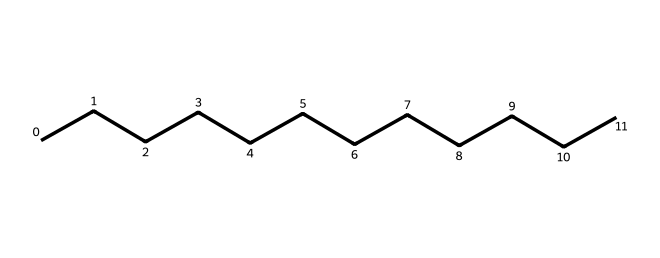What is the molecular formula of this chemical? The chemical structure provided is a linear aliphatic hydrocarbon with twelve carbon atoms, as indicated by the continuous chain of 'C's in the SMILES representation. Each carbon is bonded to hydrogen atoms to satisfy carbon's valency of four. Since there are 12 carbon atoms, using the general formula for alkanes (C_nH_(2n+2)), we find that the molecular formula is C12H26.
Answer: C12H26 How many carbon atoms does this chemical contain? The SMILES representation clearly shows twelve 'C' symbols in a continuous chain, indicating that there are twelve carbon atoms present in the structure.
Answer: 12 What type of chemical is this compound? The chemical structure is a long-chain alkane, specifically a straight-chain saturated hydrocarbon. This is evident from the continuous chain of carbon atoms without any double or triple bonds, which characterizes alkanes.
Answer: alkane What is the total number of hydrogen atoms in this chemical? The total number of hydrogen atoms can be calculated using the molecular formula derived from the structure. For a linear alkane with 12 carbon atoms, the formula gives 2n + 2 hydrogen atoms, where n is the number of carbon atoms. Thus, 2(12) + 2 results in 26 hydrogen atoms.
Answer: 26 Does this chemical have any functional groups? Upon examining the structure, there are no functional groups present, as the compound is entirely made up of single bonds between carbon and hydrogen, characteristic of alkanes.
Answer: no What is the state of this chemical at room temperature? Given that the compound is a long-chain alkane (C12H26), it is typically found in a liquid state at room temperature, owing to its molecular weight and structure.
Answer: liquid 